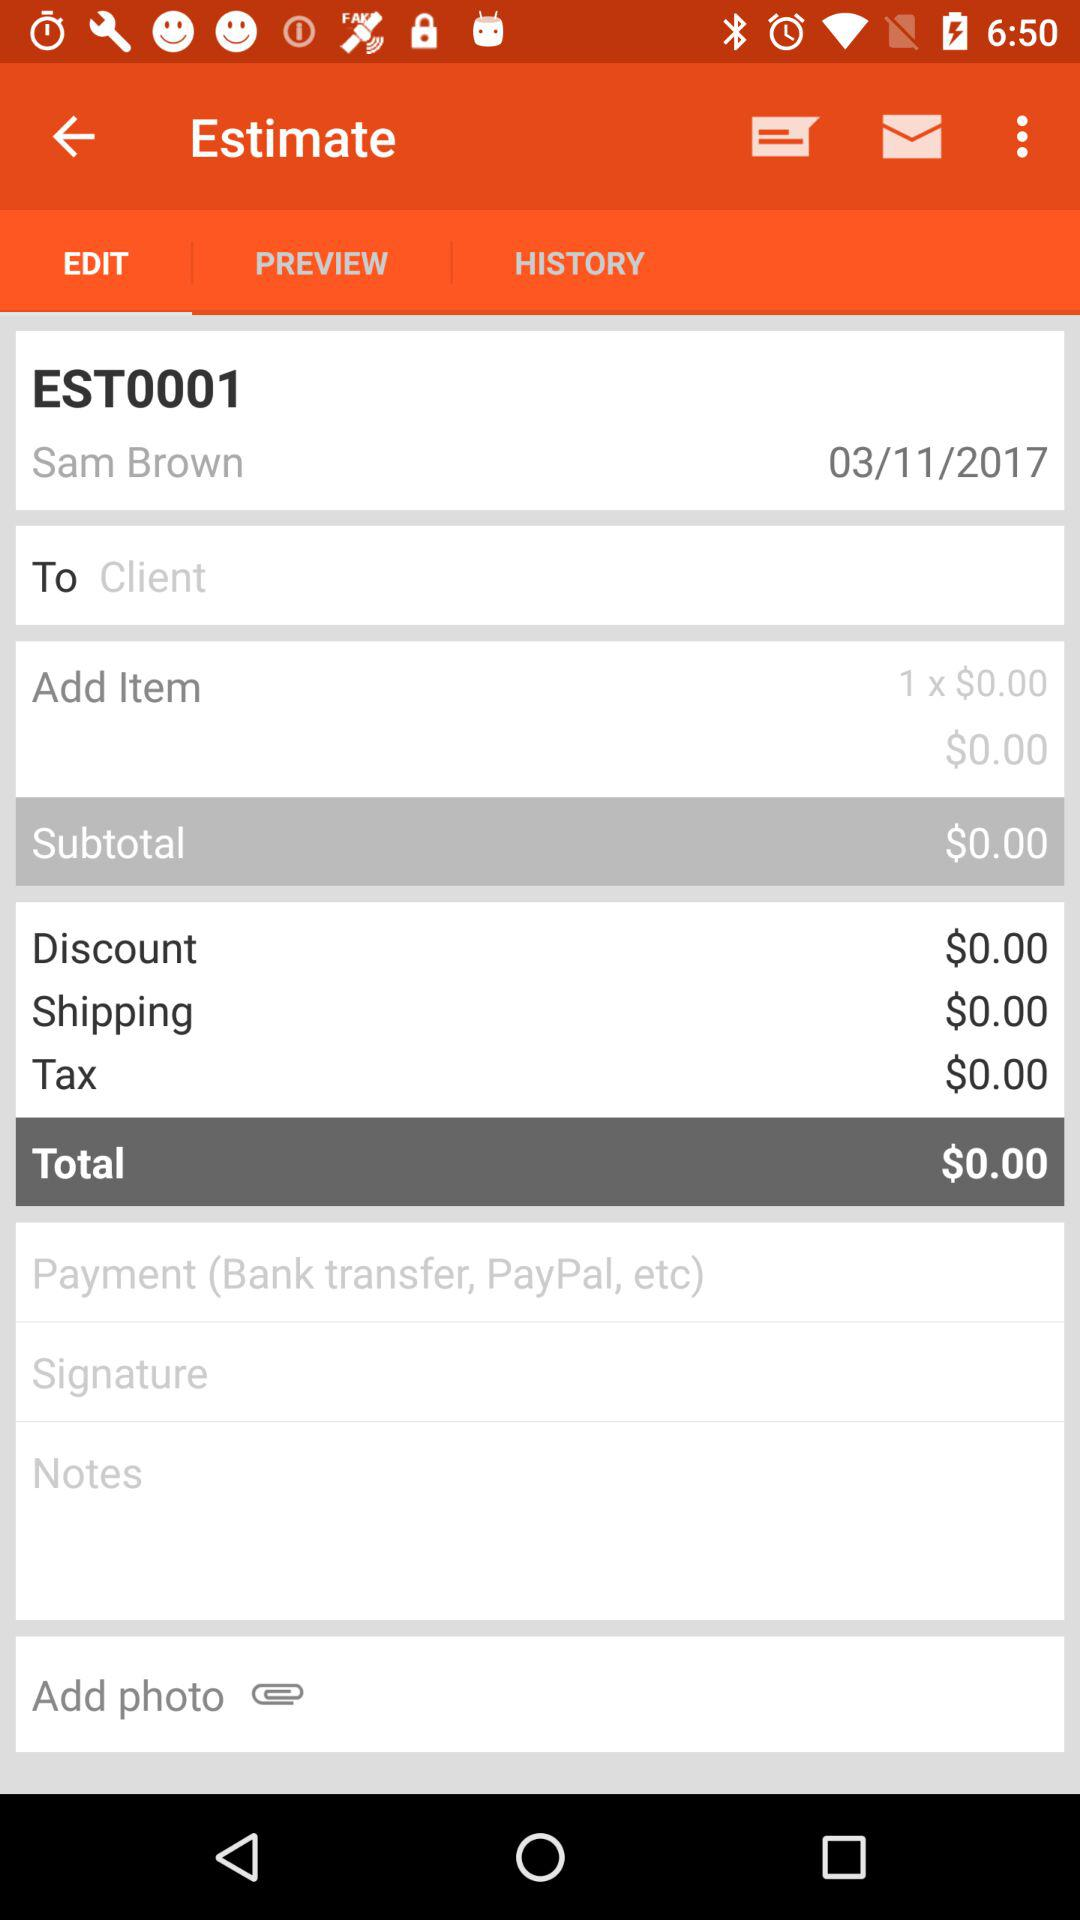What is the user name? The user name is Sam Brown. 